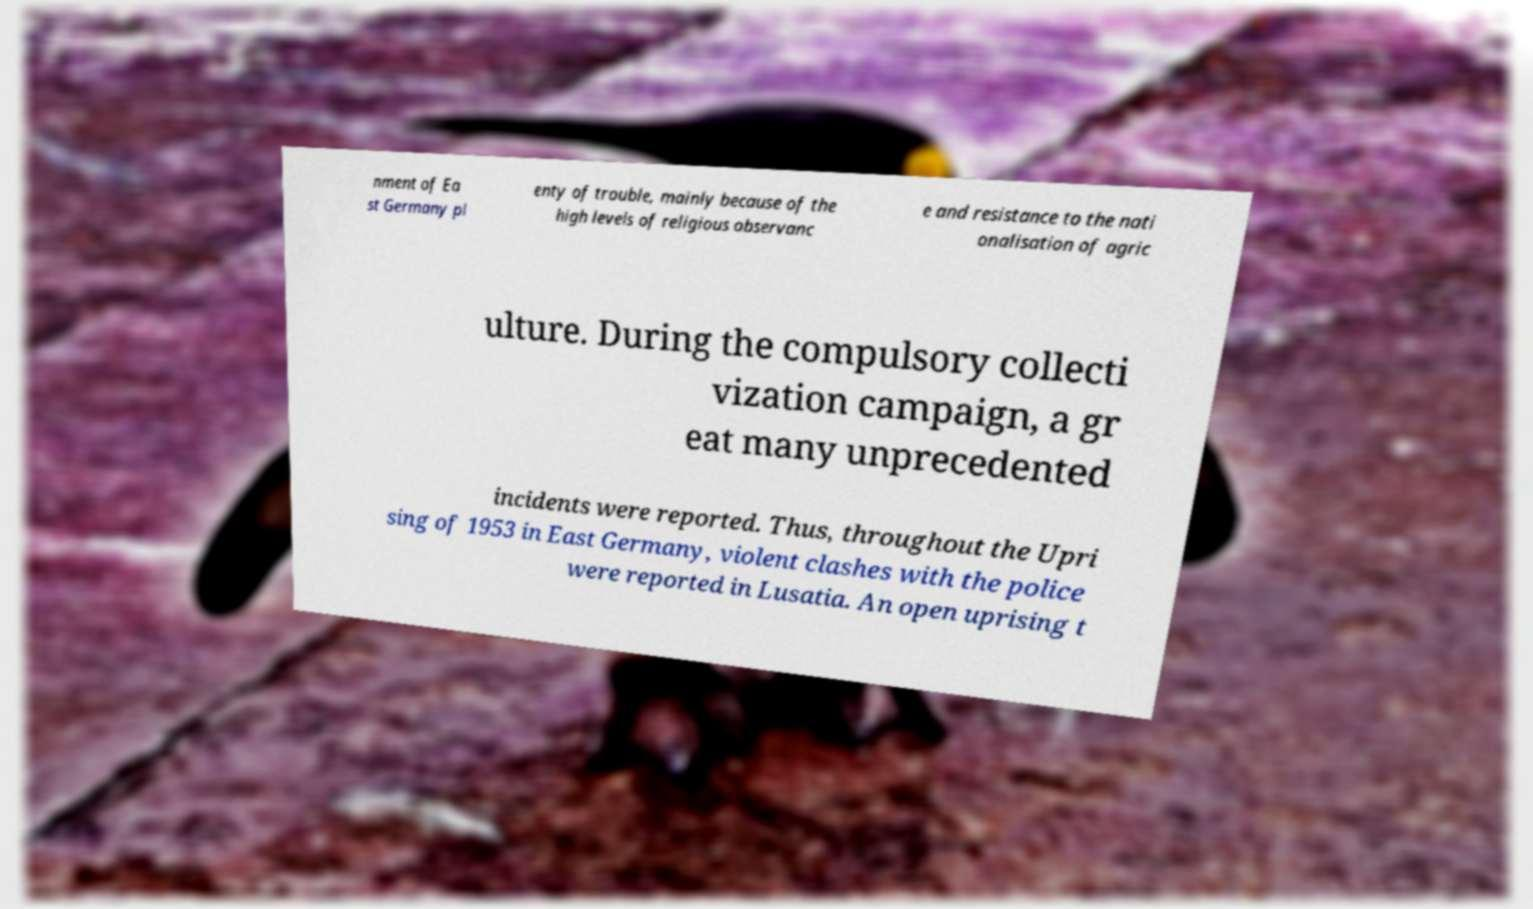Please identify and transcribe the text found in this image. nment of Ea st Germany pl enty of trouble, mainly because of the high levels of religious observanc e and resistance to the nati onalisation of agric ulture. During the compulsory collecti vization campaign, a gr eat many unprecedented incidents were reported. Thus, throughout the Upri sing of 1953 in East Germany, violent clashes with the police were reported in Lusatia. An open uprising t 